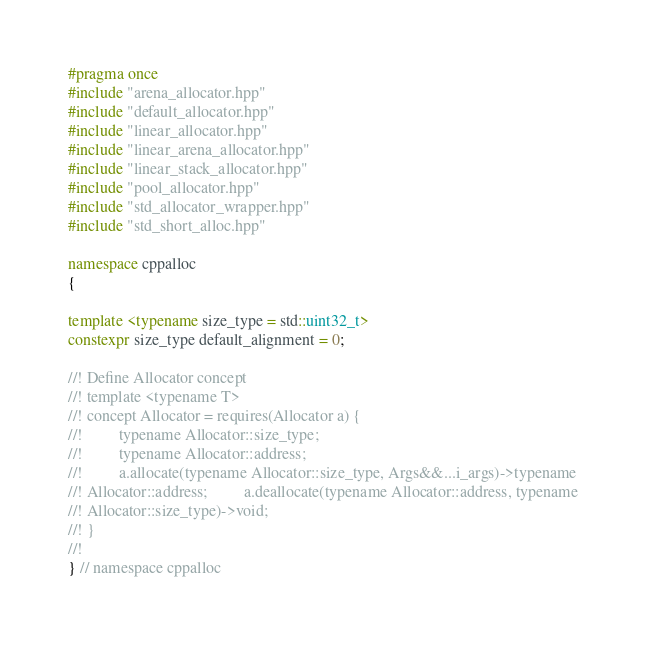<code> <loc_0><loc_0><loc_500><loc_500><_C++_>
#pragma once
#include "arena_allocator.hpp"
#include "default_allocator.hpp"
#include "linear_allocator.hpp"
#include "linear_arena_allocator.hpp"
#include "linear_stack_allocator.hpp"
#include "pool_allocator.hpp"
#include "std_allocator_wrapper.hpp"
#include "std_short_alloc.hpp"

namespace cppalloc
{

template <typename size_type = std::uint32_t>
constexpr size_type default_alignment = 0;

//! Define Allocator concept
//! template <typename T>
//! concept Allocator = requires(Allocator a) {
//! 		typename Allocator::size_type;
//! 		typename Allocator::address;
//! 		a.allocate(typename Allocator::size_type, Args&&...i_args)->typename
//! Allocator::address; 		a.deallocate(typename Allocator::address, typename
//! Allocator::size_type)->void;
//! }
//!
} // namespace cppalloc</code> 